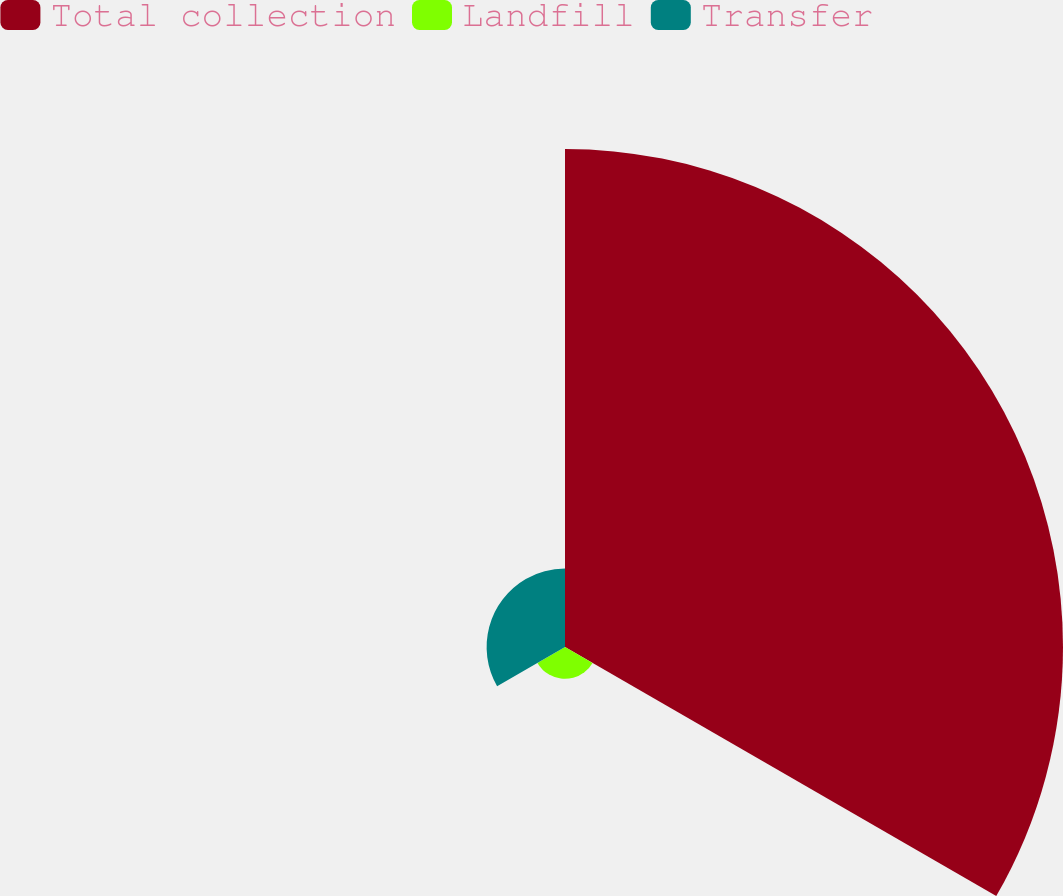<chart> <loc_0><loc_0><loc_500><loc_500><pie_chart><fcel>Total collection<fcel>Landfill<fcel>Transfer<nl><fcel>81.88%<fcel>5.23%<fcel>12.89%<nl></chart> 